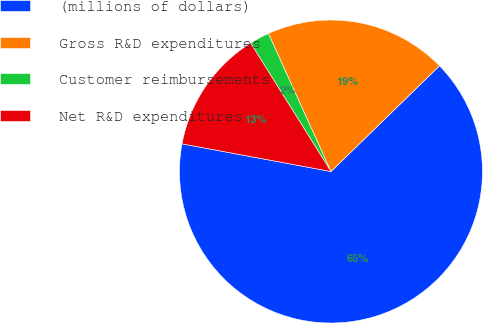Convert chart. <chart><loc_0><loc_0><loc_500><loc_500><pie_chart><fcel>(millions of dollars)<fcel>Gross R&D expenditures<fcel>Customer reimbursements<fcel>Net R&D expenditures<nl><fcel>65.22%<fcel>19.49%<fcel>2.12%<fcel>13.18%<nl></chart> 